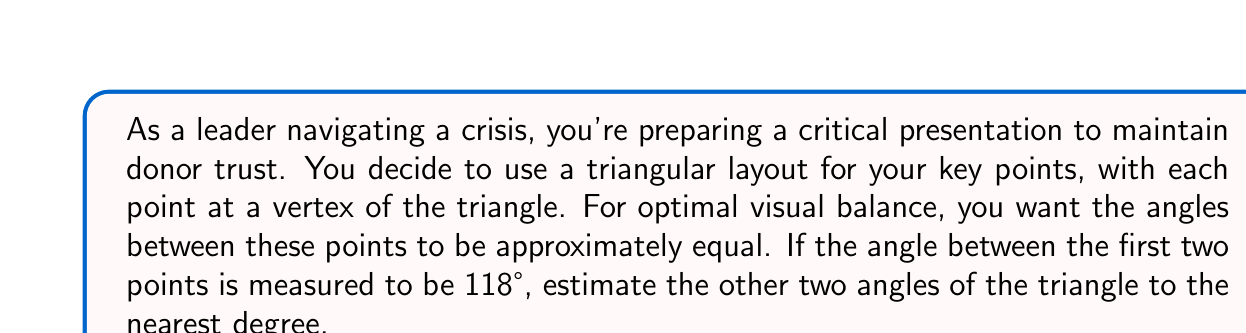Solve this math problem. Let's approach this step-by-step:

1) In a triangle, we know that the sum of all interior angles is always 180°. This is expressed mathematically as:

   $$a + b + c = 180°$$

   where $a$, $b$, and $c$ are the three angles of the triangle.

2) We're told that one angle is 118°. Let's call this angle $a$.

3) For optimal visual balance, we want the other two angles to be approximately equal. Let's call each of these angles $x$. So our equation becomes:

   $$118° + x + x = 180°$$

4) Simplify:

   $$118° + 2x = 180°$$

5) Subtract 118° from both sides:

   $$2x = 62°$$

6) Divide both sides by 2:

   $$x = 31°$$

7) However, this is an exact calculation. The question asks for an estimate to the nearest degree, so we'll round 31° to the nearest degree, which is still 31°.

Therefore, the other two angles of the triangle should each be approximately 31°.

To verify:
$$118° + 31° + 31° = 180°$$

This satisfies the requirement that the sum of angles in a triangle is 180°.

[asy]
import geometry;

size(200);
draw((0,0)--(100,173)--(200,0)--cycle);
label("118°", (100,0), S);
label("31°", (0,0), SW);
label("31°", (200,0), SE);
[/asy]
Answer: The other two angles of the triangle should each be approximately 31°. 